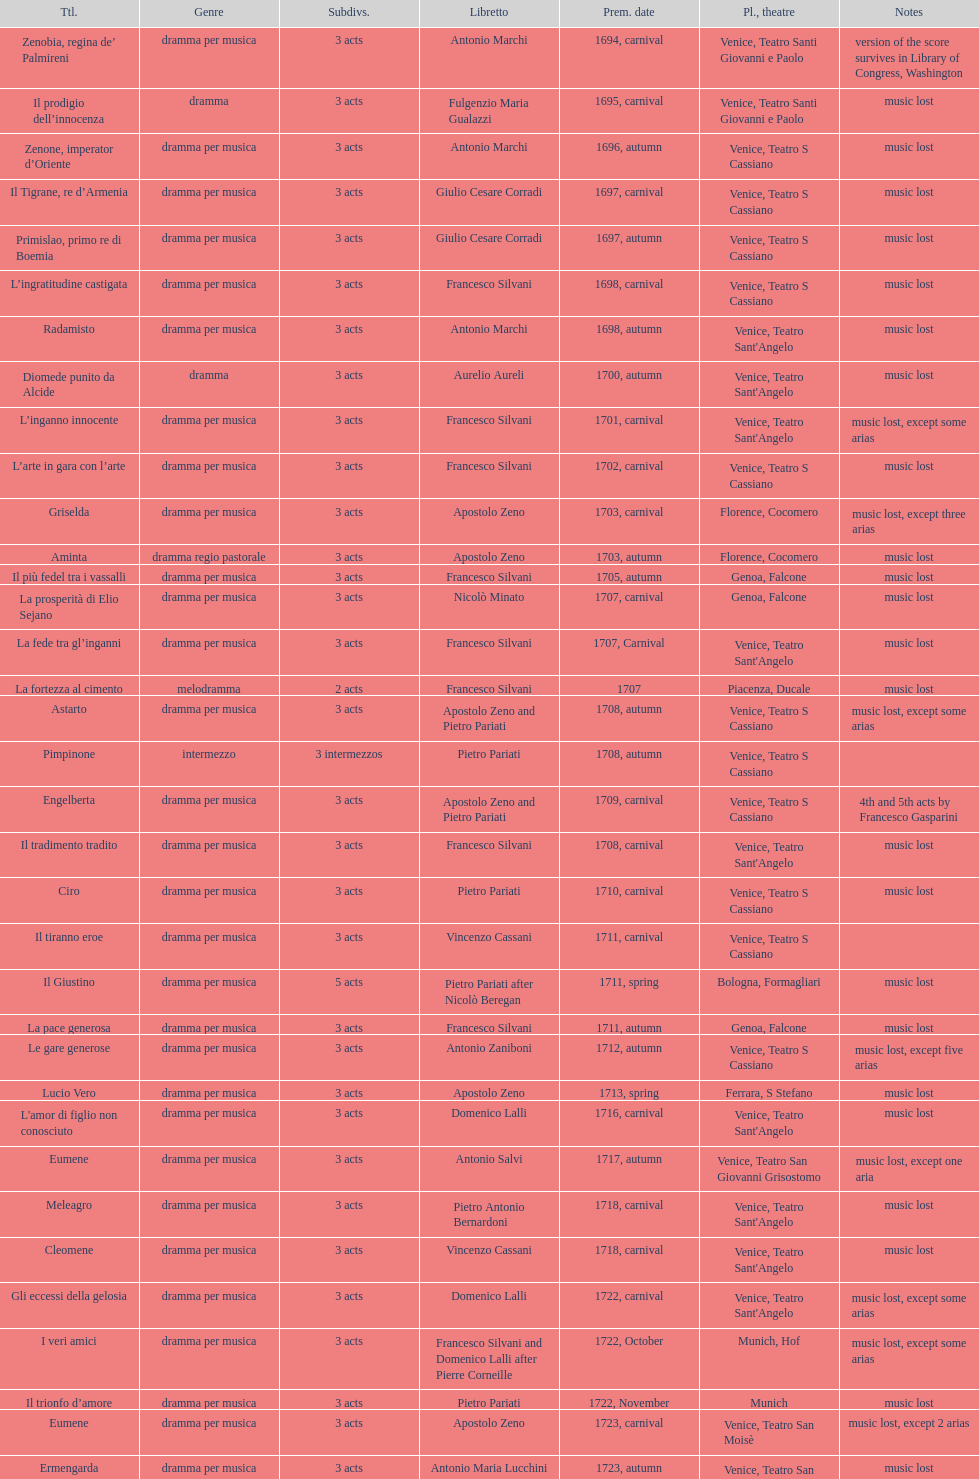What is next after ardelinda? Candalide. Would you mind parsing the complete table? {'header': ['Ttl.', 'Genre', 'Sub\xaddivs.', 'Libretto', 'Prem. date', 'Pl., theatre', 'Notes'], 'rows': [['Zenobia, regina de’ Palmireni', 'dramma per musica', '3 acts', 'Antonio Marchi', '1694, carnival', 'Venice, Teatro Santi Giovanni e Paolo', 'version of the score survives in Library of Congress, Washington'], ['Il prodigio dell’innocenza', 'dramma', '3 acts', 'Fulgenzio Maria Gualazzi', '1695, carnival', 'Venice, Teatro Santi Giovanni e Paolo', 'music lost'], ['Zenone, imperator d’Oriente', 'dramma per musica', '3 acts', 'Antonio Marchi', '1696, autumn', 'Venice, Teatro S Cassiano', 'music lost'], ['Il Tigrane, re d’Armenia', 'dramma per musica', '3 acts', 'Giulio Cesare Corradi', '1697, carnival', 'Venice, Teatro S Cassiano', 'music lost'], ['Primislao, primo re di Boemia', 'dramma per musica', '3 acts', 'Giulio Cesare Corradi', '1697, autumn', 'Venice, Teatro S Cassiano', 'music lost'], ['L’ingratitudine castigata', 'dramma per musica', '3 acts', 'Francesco Silvani', '1698, carnival', 'Venice, Teatro S Cassiano', 'music lost'], ['Radamisto', 'dramma per musica', '3 acts', 'Antonio Marchi', '1698, autumn', "Venice, Teatro Sant'Angelo", 'music lost'], ['Diomede punito da Alcide', 'dramma', '3 acts', 'Aurelio Aureli', '1700, autumn', "Venice, Teatro Sant'Angelo", 'music lost'], ['L’inganno innocente', 'dramma per musica', '3 acts', 'Francesco Silvani', '1701, carnival', "Venice, Teatro Sant'Angelo", 'music lost, except some arias'], ['L’arte in gara con l’arte', 'dramma per musica', '3 acts', 'Francesco Silvani', '1702, carnival', 'Venice, Teatro S Cassiano', 'music lost'], ['Griselda', 'dramma per musica', '3 acts', 'Apostolo Zeno', '1703, carnival', 'Florence, Cocomero', 'music lost, except three arias'], ['Aminta', 'dramma regio pastorale', '3 acts', 'Apostolo Zeno', '1703, autumn', 'Florence, Cocomero', 'music lost'], ['Il più fedel tra i vassalli', 'dramma per musica', '3 acts', 'Francesco Silvani', '1705, autumn', 'Genoa, Falcone', 'music lost'], ['La prosperità di Elio Sejano', 'dramma per musica', '3 acts', 'Nicolò Minato', '1707, carnival', 'Genoa, Falcone', 'music lost'], ['La fede tra gl’inganni', 'dramma per musica', '3 acts', 'Francesco Silvani', '1707, Carnival', "Venice, Teatro Sant'Angelo", 'music lost'], ['La fortezza al cimento', 'melodramma', '2 acts', 'Francesco Silvani', '1707', 'Piacenza, Ducale', 'music lost'], ['Astarto', 'dramma per musica', '3 acts', 'Apostolo Zeno and Pietro Pariati', '1708, autumn', 'Venice, Teatro S Cassiano', 'music lost, except some arias'], ['Pimpinone', 'intermezzo', '3 intermezzos', 'Pietro Pariati', '1708, autumn', 'Venice, Teatro S Cassiano', ''], ['Engelberta', 'dramma per musica', '3 acts', 'Apostolo Zeno and Pietro Pariati', '1709, carnival', 'Venice, Teatro S Cassiano', '4th and 5th acts by Francesco Gasparini'], ['Il tradimento tradito', 'dramma per musica', '3 acts', 'Francesco Silvani', '1708, carnival', "Venice, Teatro Sant'Angelo", 'music lost'], ['Ciro', 'dramma per musica', '3 acts', 'Pietro Pariati', '1710, carnival', 'Venice, Teatro S Cassiano', 'music lost'], ['Il tiranno eroe', 'dramma per musica', '3 acts', 'Vincenzo Cassani', '1711, carnival', 'Venice, Teatro S Cassiano', ''], ['Il Giustino', 'dramma per musica', '5 acts', 'Pietro Pariati after Nicolò Beregan', '1711, spring', 'Bologna, Formagliari', 'music lost'], ['La pace generosa', 'dramma per musica', '3 acts', 'Francesco Silvani', '1711, autumn', 'Genoa, Falcone', 'music lost'], ['Le gare generose', 'dramma per musica', '3 acts', 'Antonio Zaniboni', '1712, autumn', 'Venice, Teatro S Cassiano', 'music lost, except five arias'], ['Lucio Vero', 'dramma per musica', '3 acts', 'Apostolo Zeno', '1713, spring', 'Ferrara, S Stefano', 'music lost'], ["L'amor di figlio non conosciuto", 'dramma per musica', '3 acts', 'Domenico Lalli', '1716, carnival', "Venice, Teatro Sant'Angelo", 'music lost'], ['Eumene', 'dramma per musica', '3 acts', 'Antonio Salvi', '1717, autumn', 'Venice, Teatro San Giovanni Grisostomo', 'music lost, except one aria'], ['Meleagro', 'dramma per musica', '3 acts', 'Pietro Antonio Bernardoni', '1718, carnival', "Venice, Teatro Sant'Angelo", 'music lost'], ['Cleomene', 'dramma per musica', '3 acts', 'Vincenzo Cassani', '1718, carnival', "Venice, Teatro Sant'Angelo", 'music lost'], ['Gli eccessi della gelosia', 'dramma per musica', '3 acts', 'Domenico Lalli', '1722, carnival', "Venice, Teatro Sant'Angelo", 'music lost, except some arias'], ['I veri amici', 'dramma per musica', '3 acts', 'Francesco Silvani and Domenico Lalli after Pierre Corneille', '1722, October', 'Munich, Hof', 'music lost, except some arias'], ['Il trionfo d’amore', 'dramma per musica', '3 acts', 'Pietro Pariati', '1722, November', 'Munich', 'music lost'], ['Eumene', 'dramma per musica', '3 acts', 'Apostolo Zeno', '1723, carnival', 'Venice, Teatro San Moisè', 'music lost, except 2 arias'], ['Ermengarda', 'dramma per musica', '3 acts', 'Antonio Maria Lucchini', '1723, autumn', 'Venice, Teatro San Moisè', 'music lost'], ['Antigono, tutore di Filippo, re di Macedonia', 'tragedia', '5 acts', 'Giovanni Piazzon', '1724, carnival', 'Venice, Teatro San Moisè', '5th act by Giovanni Porta, music lost'], ['Scipione nelle Spagne', 'dramma per musica', '3 acts', 'Apostolo Zeno', '1724, Ascension', 'Venice, Teatro San Samuele', 'music lost'], ['Laodice', 'dramma per musica', '3 acts', 'Angelo Schietti', '1724, autumn', 'Venice, Teatro San Moisè', 'music lost, except 2 arias'], ['Didone abbandonata', 'tragedia', '3 acts', 'Metastasio', '1725, carnival', 'Venice, Teatro S Cassiano', 'music lost'], ["L'impresario delle Isole Canarie", 'intermezzo', '2 acts', 'Metastasio', '1725, carnival', 'Venice, Teatro S Cassiano', 'music lost'], ['Alcina delusa da Ruggero', 'dramma per musica', '3 acts', 'Antonio Marchi', '1725, autumn', 'Venice, Teatro S Cassiano', 'music lost'], ['I rivali generosi', 'dramma per musica', '3 acts', 'Apostolo Zeno', '1725', 'Brescia, Nuovo', ''], ['La Statira', 'dramma per musica', '3 acts', 'Apostolo Zeno and Pietro Pariati', '1726, Carnival', 'Rome, Teatro Capranica', ''], ['Malsazio e Fiammetta', 'intermezzo', '', '', '1726, Carnival', 'Rome, Teatro Capranica', ''], ['Il trionfo di Armida', 'dramma per musica', '3 acts', 'Girolamo Colatelli after Torquato Tasso', '1726, autumn', 'Venice, Teatro San Moisè', 'music lost'], ['L’incostanza schernita', 'dramma comico-pastorale', '3 acts', 'Vincenzo Cassani', '1727, Ascension', 'Venice, Teatro San Samuele', 'music lost, except some arias'], ['Le due rivali in amore', 'dramma per musica', '3 acts', 'Aurelio Aureli', '1728, autumn', 'Venice, Teatro San Moisè', 'music lost'], ['Il Satrapone', 'intermezzo', '', 'Salvi', '1729', 'Parma, Omodeo', ''], ['Li stratagemmi amorosi', 'dramma per musica', '3 acts', 'F Passerini', '1730, carnival', 'Venice, Teatro San Moisè', 'music lost'], ['Elenia', 'dramma per musica', '3 acts', 'Luisa Bergalli', '1730, carnival', "Venice, Teatro Sant'Angelo", 'music lost'], ['Merope', 'dramma', '3 acts', 'Apostolo Zeno', '1731, autumn', 'Prague, Sporck Theater', 'mostly by Albinoni, music lost'], ['Il più infedel tra gli amanti', 'dramma per musica', '3 acts', 'Angelo Schietti', '1731, autumn', 'Treviso, Dolphin', 'music lost'], ['Ardelinda', 'dramma', '3 acts', 'Bartolomeo Vitturi', '1732, autumn', "Venice, Teatro Sant'Angelo", 'music lost, except five arias'], ['Candalide', 'dramma per musica', '3 acts', 'Bartolomeo Vitturi', '1734, carnival', "Venice, Teatro Sant'Angelo", 'music lost'], ['Artamene', 'dramma per musica', '3 acts', 'Bartolomeo Vitturi', '1741, carnival', "Venice, Teatro Sant'Angelo", 'music lost']]} 